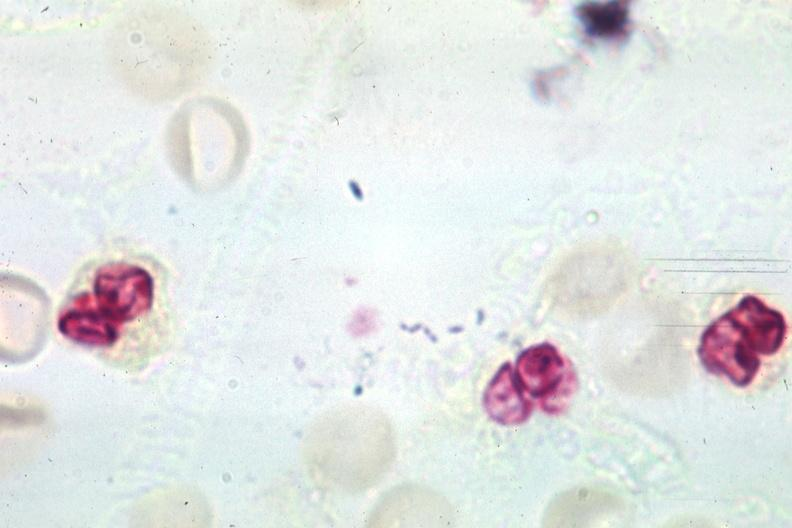s cryptosporidia present?
Answer the question using a single word or phrase. No 